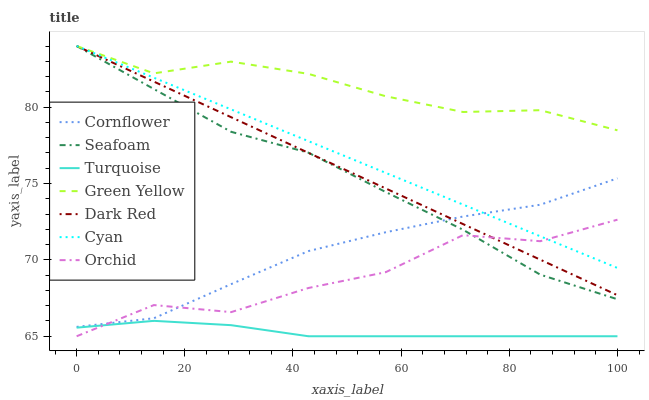Does Turquoise have the minimum area under the curve?
Answer yes or no. Yes. Does Green Yellow have the maximum area under the curve?
Answer yes or no. Yes. Does Dark Red have the minimum area under the curve?
Answer yes or no. No. Does Dark Red have the maximum area under the curve?
Answer yes or no. No. Is Cyan the smoothest?
Answer yes or no. Yes. Is Orchid the roughest?
Answer yes or no. Yes. Is Turquoise the smoothest?
Answer yes or no. No. Is Turquoise the roughest?
Answer yes or no. No. Does Turquoise have the lowest value?
Answer yes or no. Yes. Does Dark Red have the lowest value?
Answer yes or no. No. Does Green Yellow have the highest value?
Answer yes or no. Yes. Does Turquoise have the highest value?
Answer yes or no. No. Is Turquoise less than Seafoam?
Answer yes or no. Yes. Is Cyan greater than Turquoise?
Answer yes or no. Yes. Does Cyan intersect Seafoam?
Answer yes or no. Yes. Is Cyan less than Seafoam?
Answer yes or no. No. Is Cyan greater than Seafoam?
Answer yes or no. No. Does Turquoise intersect Seafoam?
Answer yes or no. No. 